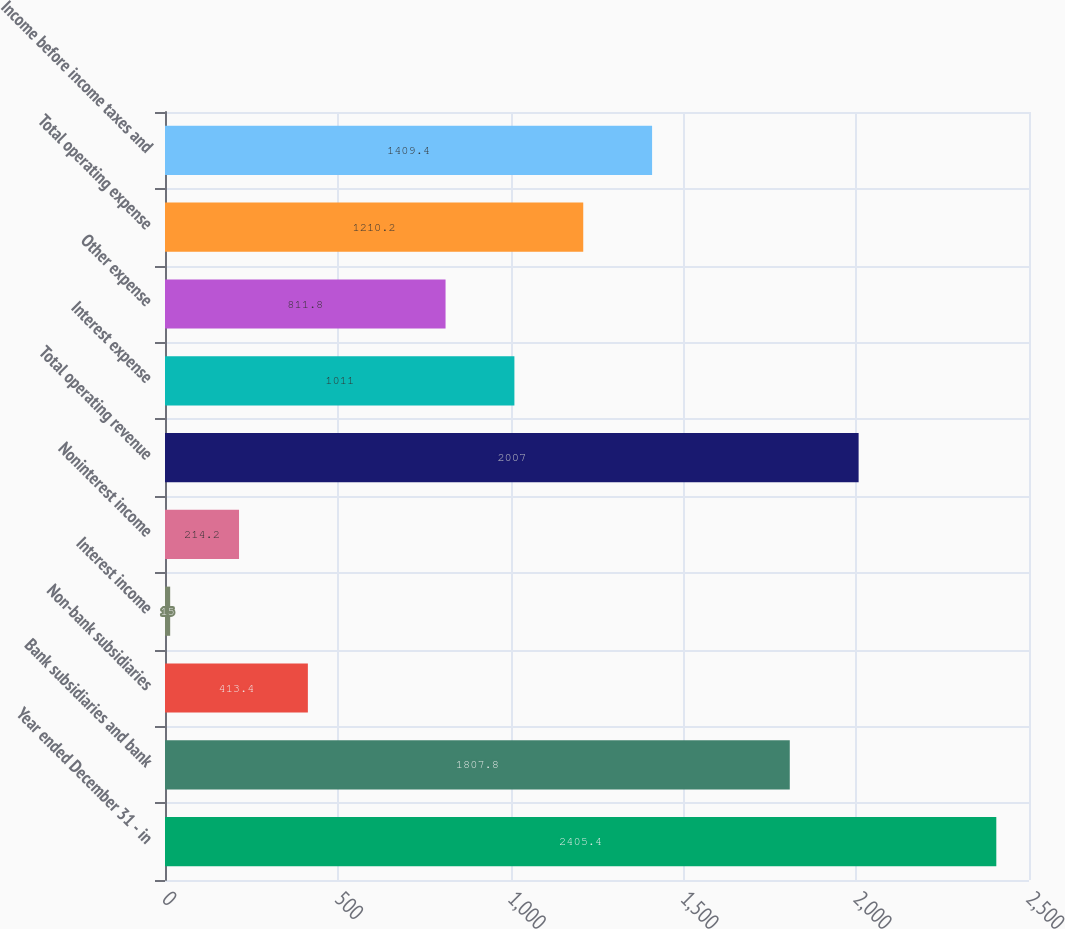<chart> <loc_0><loc_0><loc_500><loc_500><bar_chart><fcel>Year ended December 31 - in<fcel>Bank subsidiaries and bank<fcel>Non-bank subsidiaries<fcel>Interest income<fcel>Noninterest income<fcel>Total operating revenue<fcel>Interest expense<fcel>Other expense<fcel>Total operating expense<fcel>Income before income taxes and<nl><fcel>2405.4<fcel>1807.8<fcel>413.4<fcel>15<fcel>214.2<fcel>2007<fcel>1011<fcel>811.8<fcel>1210.2<fcel>1409.4<nl></chart> 